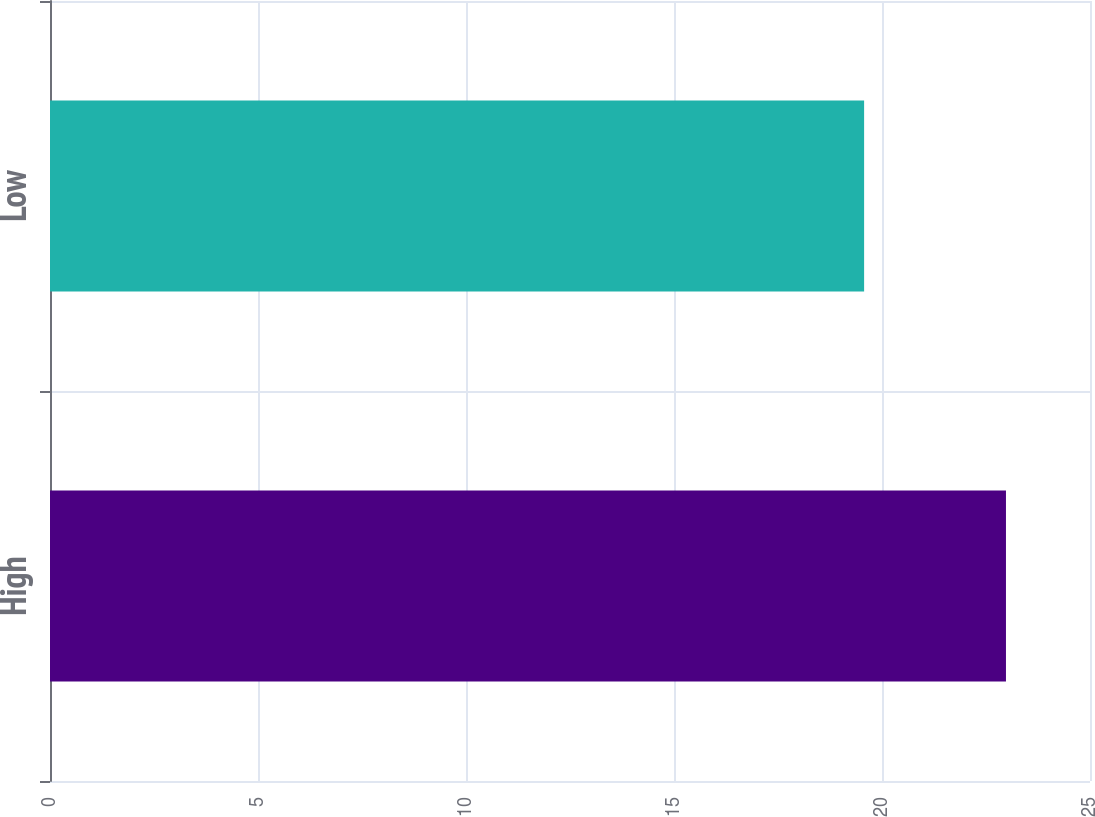Convert chart. <chart><loc_0><loc_0><loc_500><loc_500><bar_chart><fcel>High<fcel>Low<nl><fcel>22.98<fcel>19.57<nl></chart> 